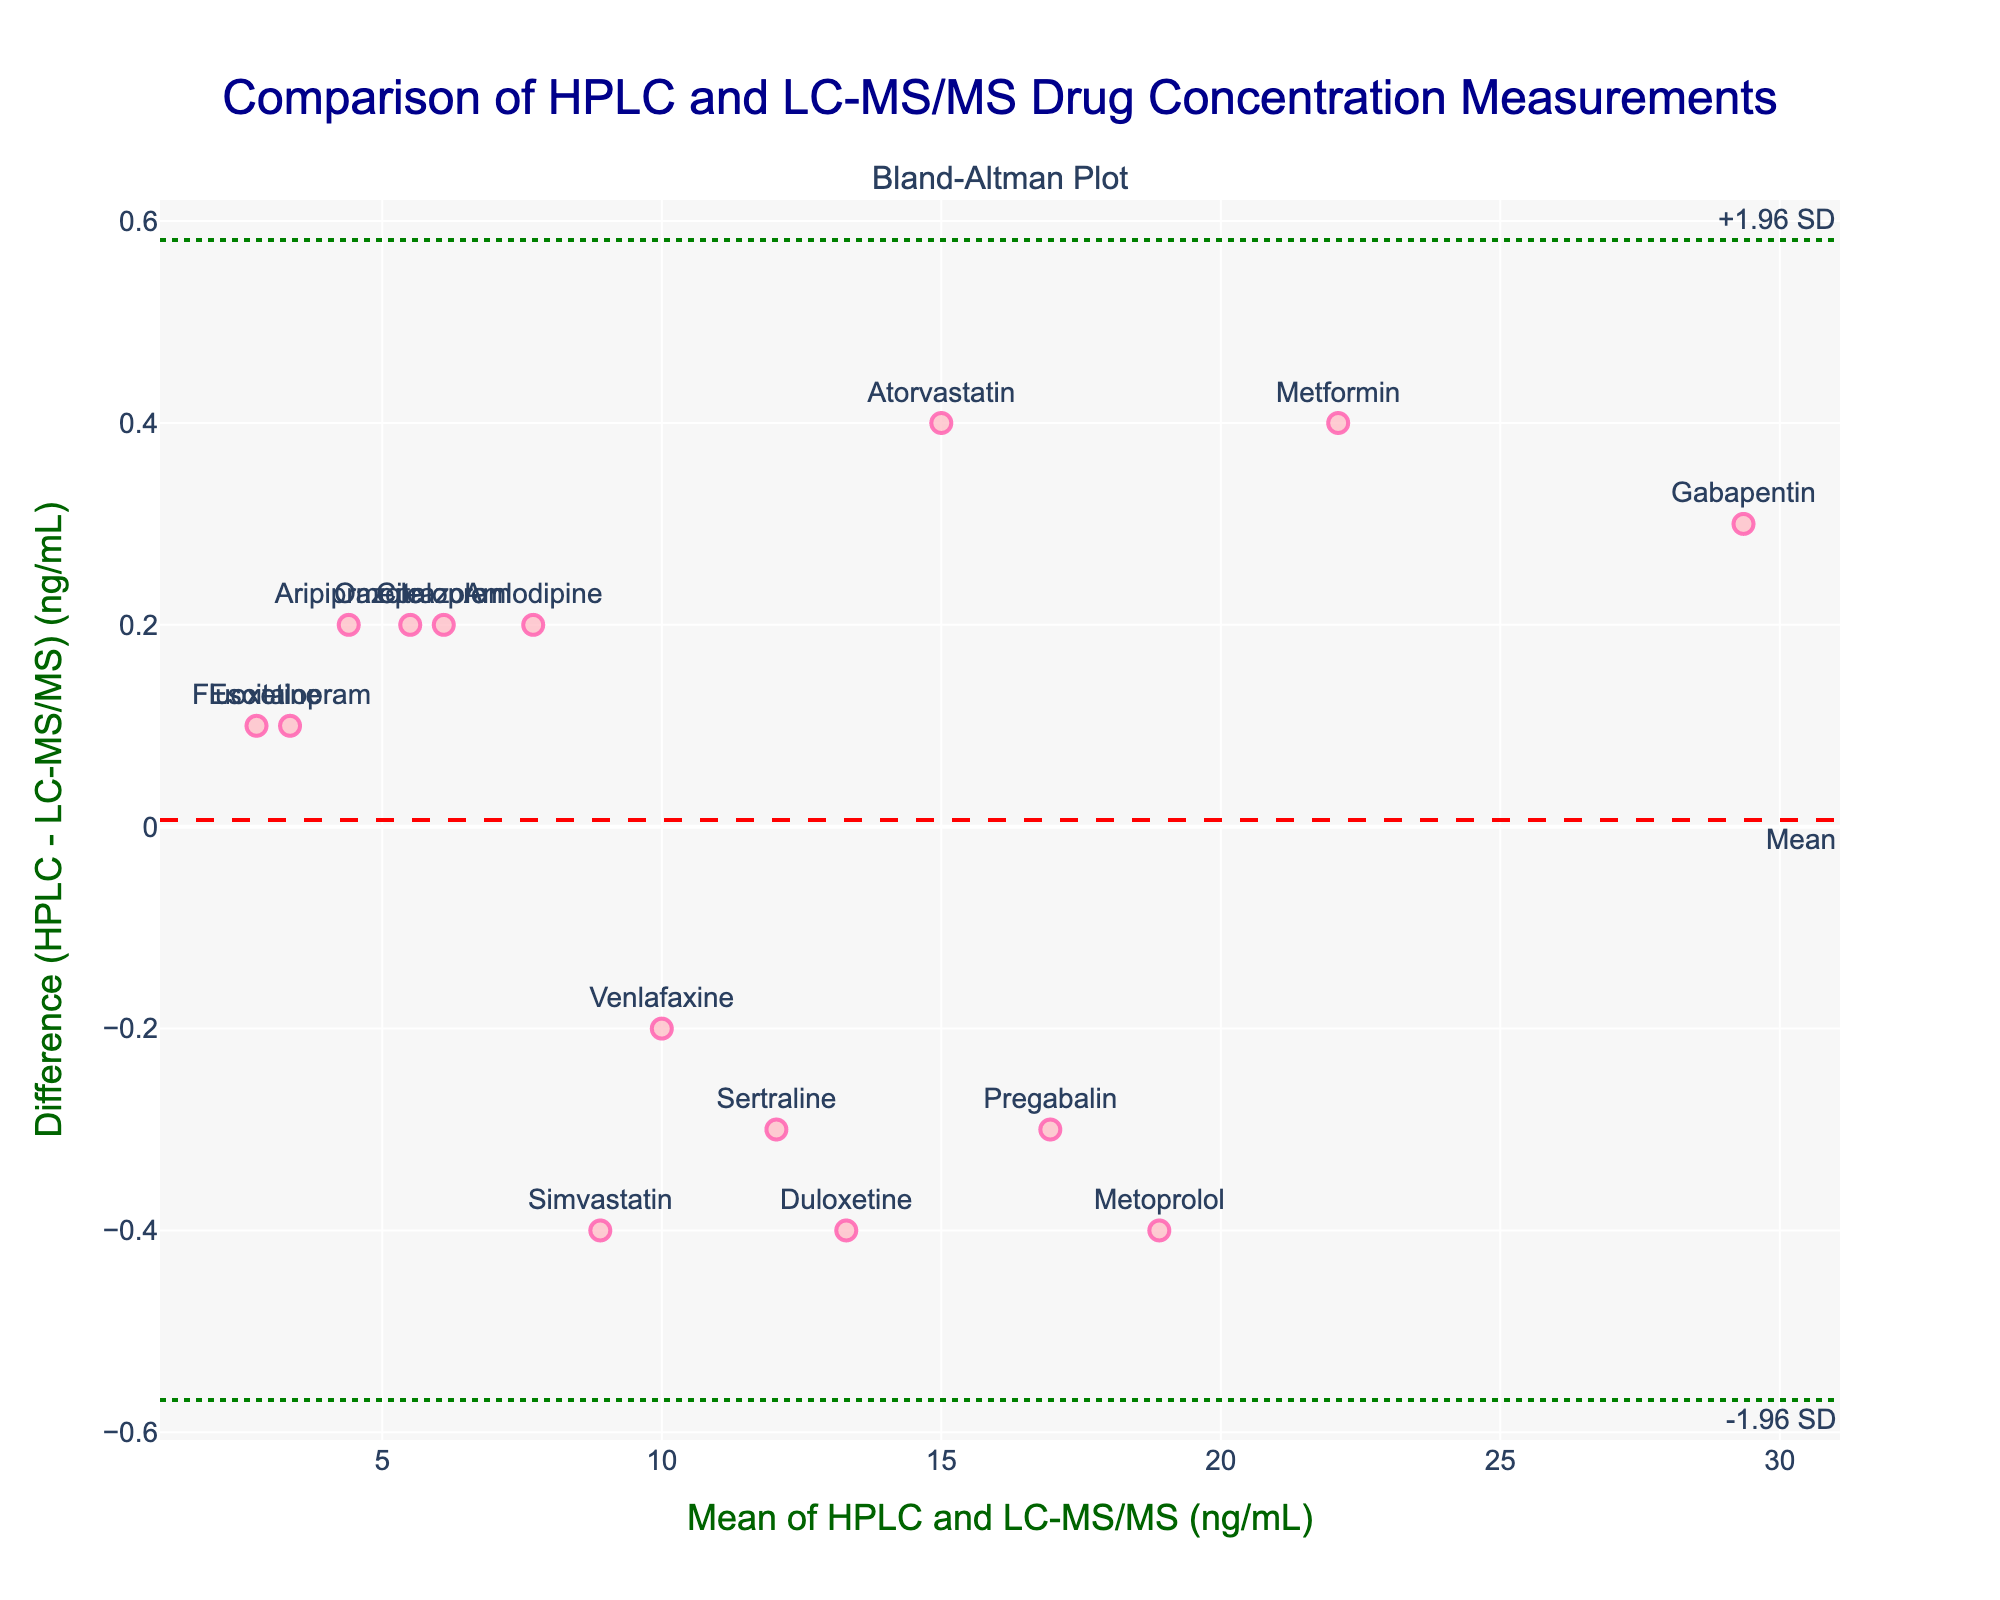What's the title of the plot? The title of the plot is clearly visible at the top and reads "Comparison of HPLC and LC-MS/MS Drug Concentration Measurements".
Answer: Comparison of HPLC and LC-MS/MS Drug Concentration Measurements What do the x-axis and y-axis represent? The x-axis represents the "Mean of HPLC and LC-MS/MS (ng/mL)" and the y-axis represents the "Difference (HPLC - LC-MS/MS) (ng/mL)".
Answer: x-axis: Mean of HPLC and LC-MS/MS (ng/mL); y-axis: Difference (HPLC - LC-MS/MS) (ng/mL) What is the mean difference between the two methods' measurements? The mean difference between the HPLC and LC-MS/MS measurements is indicated by the dashed red line along the y-axis. It is labeled "Mean".
Answer: Mean difference Which drug has the highest mean concentration? The mean concentration for each drug can be found by looking at the x-values of the scatter plot. Gabapentin, located at the highest x-value, has the highest mean concentration.
Answer: Gabapentin What are the upper and lower limits of agreement? The upper limit of agreement is shown by the upper green dotted line labeled "+1.96 SD", and the lower limit of agreement is shown by the lower green dotted line labeled "-1.96 SD". These lines represent the bounds where 95% of the data differences would lie.
Answer: Upper: +1.96 SD; Lower: -1.96 SD Which drugs have a positive difference, meaning HPLC concentration is higher than LC-MS/MS? Positive differences are shown above the y=0 line. By observing the plot, drugs with a positive difference include Atorvastatin, Omeprazole, Aripiprazole, and Citalopram.
Answer: Atorvastatin, Omeprazole, Aripiprazole, Citalopram What's the concentration difference for Escitalopram? For Escitalopram, the difference is the y-value at its respective point on the scatter plot. By locating Escitalopram, we find the y-value to be slightly above 0, specifically 0.1.
Answer: 0.1 ng/mL How many drugs fall outside the limits of agreement? By examining the scatter plot, observe how many points fall outside the green dotted lines. In this case, no points fall outside these limits.
Answer: 0 drugs Which method tends to measure higher concentrations overall? By examining the positions of the points relative to the y=0 line, more drugs have a negative difference (LC-MS/MS measures higher). The mean difference is also slightly negative.
Answer: LC-MS/MS What can you infer from the spread of data points around the mean difference? The consistent spread of data points around the mean difference line, within the limits of agreement, suggests good agreement and similar variability between the two methods.
Answer: Good agreement 